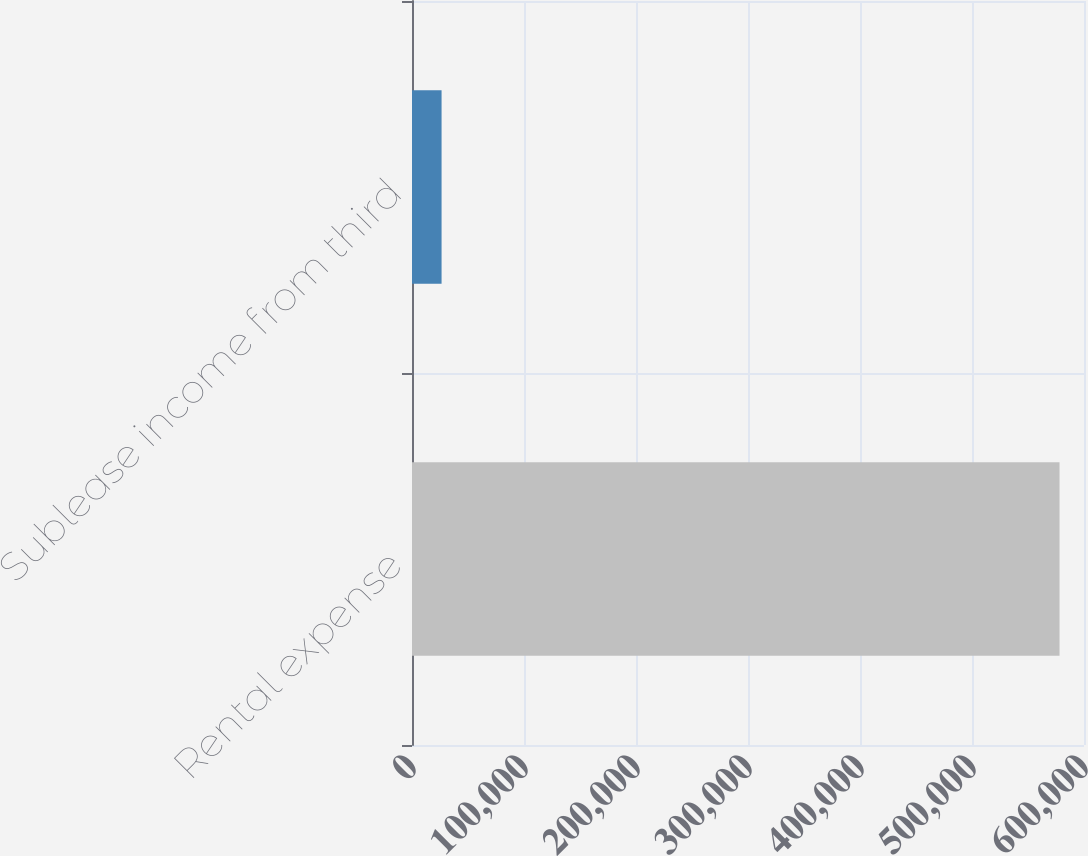<chart> <loc_0><loc_0><loc_500><loc_500><bar_chart><fcel>Rental expense<fcel>Sublease income from third<nl><fcel>578149<fcel>26403<nl></chart> 